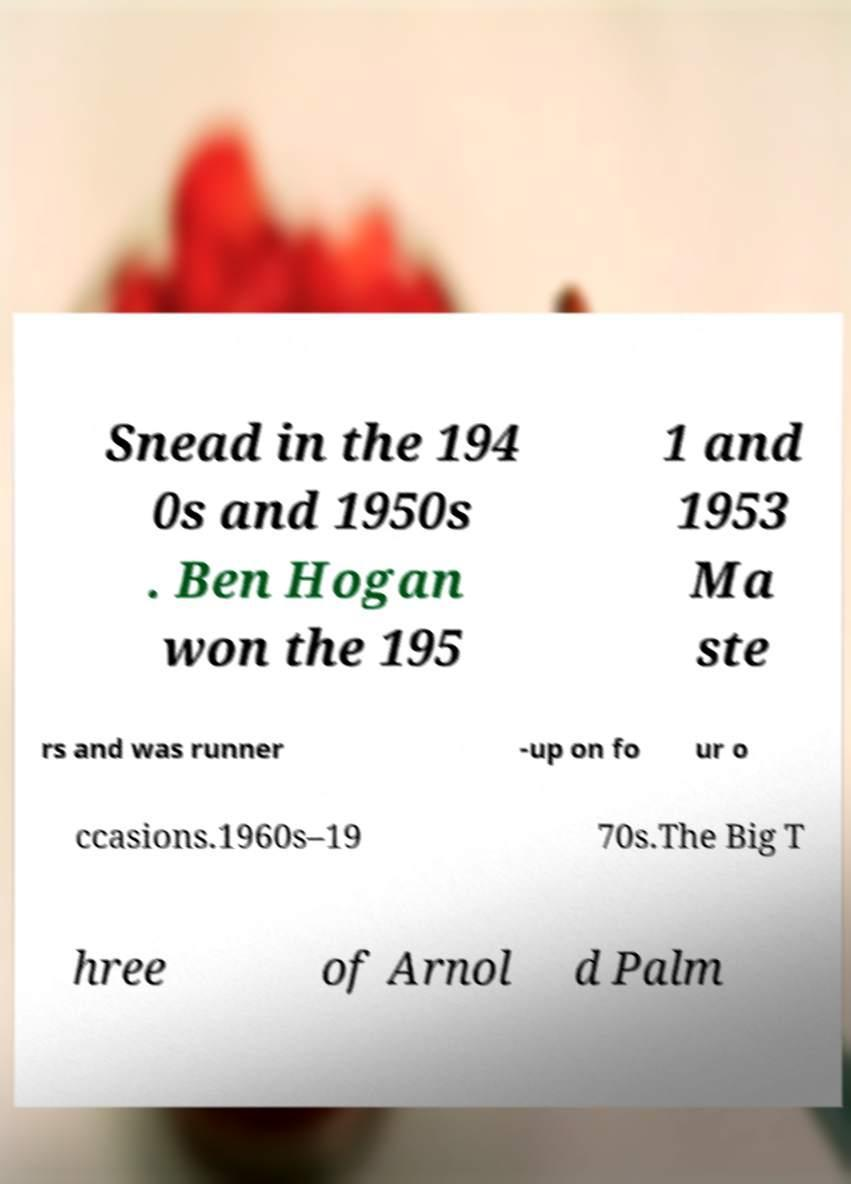What messages or text are displayed in this image? I need them in a readable, typed format. Snead in the 194 0s and 1950s . Ben Hogan won the 195 1 and 1953 Ma ste rs and was runner -up on fo ur o ccasions.1960s–19 70s.The Big T hree of Arnol d Palm 